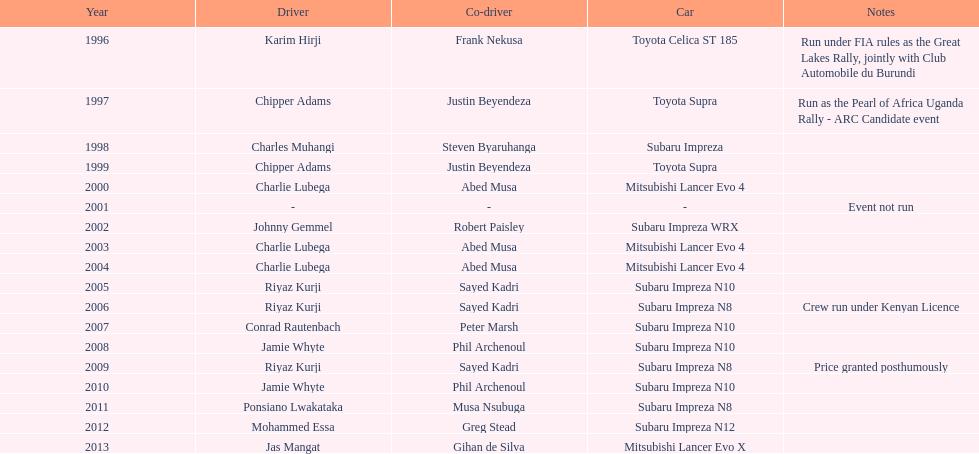Chipper adams and justin beyendeza have how many triumphs? 2. 